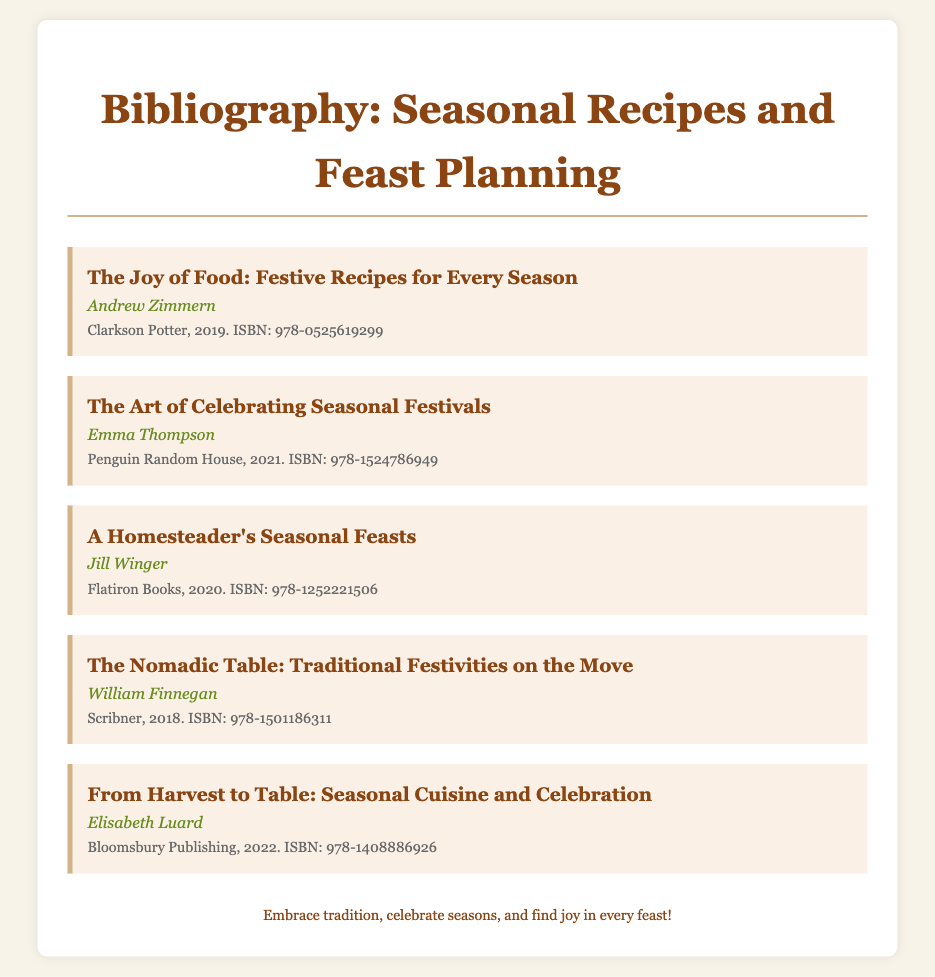What is the title of the first book? The first book listed is "The Joy of Food: Festive Recipes for Every Season."
Answer: The Joy of Food: Festive Recipes for Every Season Who is the author of "The Art of Celebrating Seasonal Festivals"? The author of this book is Emma Thompson.
Answer: Emma Thompson What year was "A Homesteader's Seasonal Feasts" published? This book was published in the year 2020.
Answer: 2020 Which publishing house released "The Nomadic Table: Traditional Festivities on the Move"? This book was released by Scribner.
Answer: Scribner How many books are listed in the bibliography? There are a total of five books listed in the bibliography.
Answer: 5 Which book focuses on seasonal cuisine and celebration? The book that focuses on this topic is "From Harvest to Table: Seasonal Cuisine and Celebration."
Answer: From Harvest to Table: Seasonal Cuisine and Celebration Who published the book with ISBN 978-1524786949? The publisher of this book is Penguin Random House.
Answer: Penguin Random House What do all the books in this bibliography have in common? All the books are related to seasonal recipes and festive planning.
Answer: Seasonal recipes and festive planning 